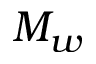Convert formula to latex. <formula><loc_0><loc_0><loc_500><loc_500>M _ { w }</formula> 